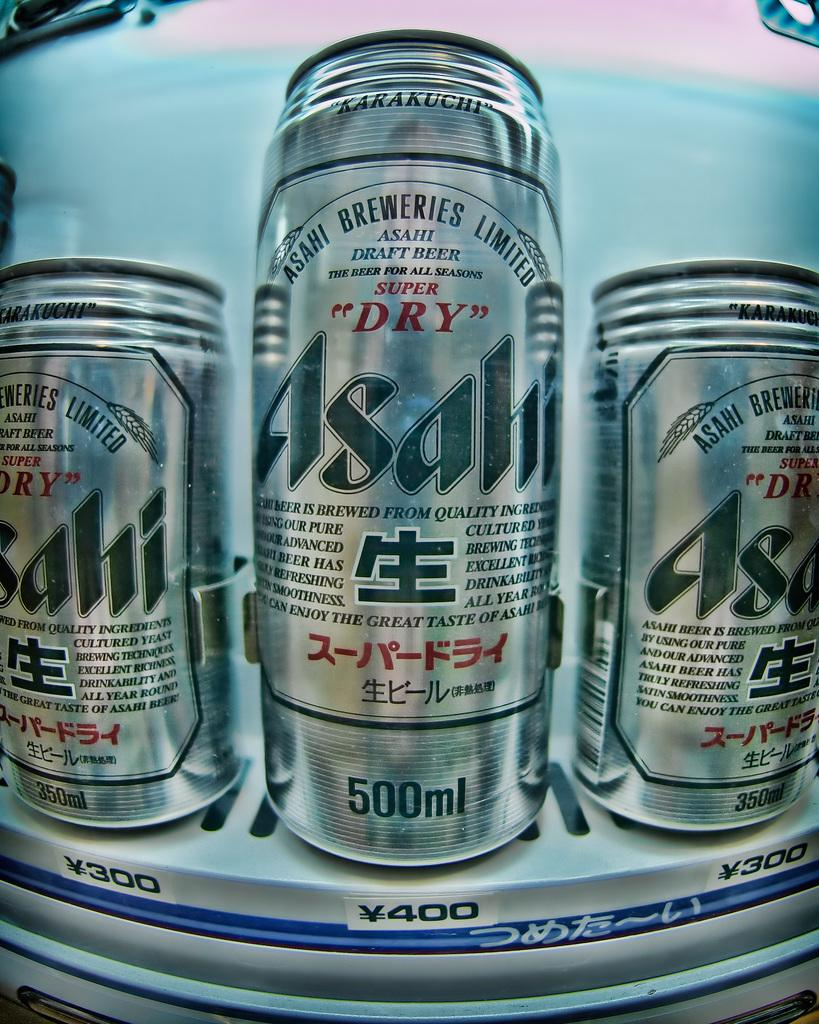<image>
Write a terse but informative summary of the picture. Two 350 ml beverage cans of Asahi beer are on the left and right side of a 500 ml can of Asahi beer. 